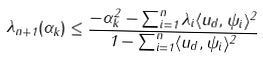Convert formula to latex. <formula><loc_0><loc_0><loc_500><loc_500>\lambda _ { n + 1 } ( \alpha _ { k } ) \leq \frac { - \alpha _ { k } ^ { 2 } - \sum _ { i = 1 } ^ { n } \lambda _ { i } \langle u _ { d } , \psi _ { i } \rangle ^ { 2 } } { 1 - \sum _ { i = 1 } ^ { n } \langle u _ { d } , \psi _ { i } \rangle ^ { 2 } }</formula> 